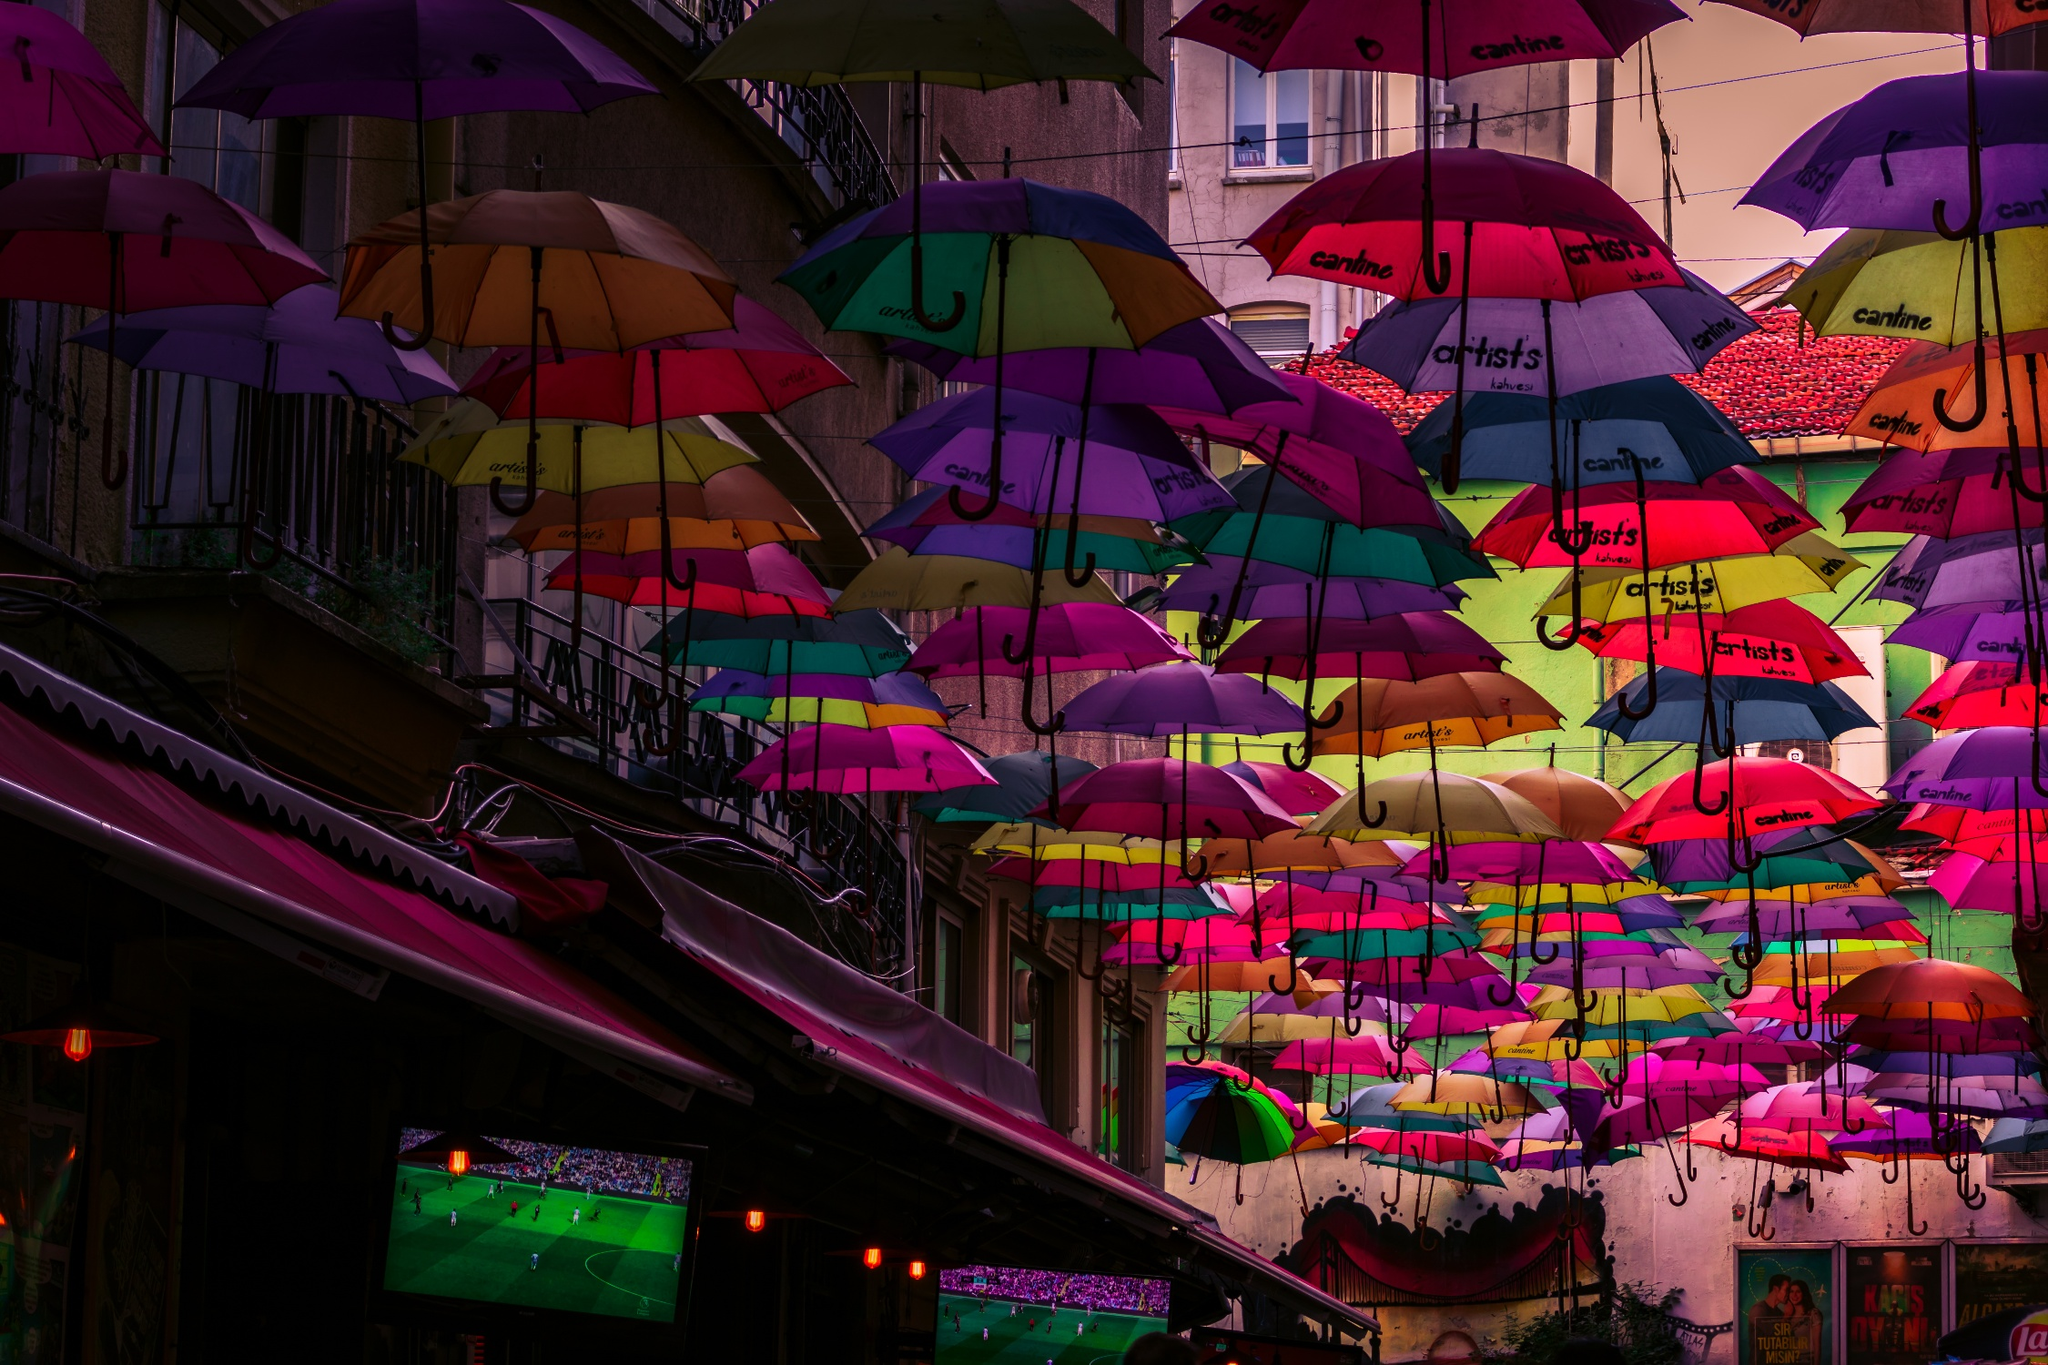What might be the impact of this colorful canopy on the local businesses? The colorful canopy of umbrellas likely boosts local commerce by drawing more visitors to the area, intrigued by the visual spectacle and vibrant atmosphere. It can enhance the street's appeal, making it a popular spot for photographs and leisurely strolls. This increased foot traffic can lead to higher sales in the nearby shops and restaurants, and the umbrellas themselves, showcasing brand names, might reflect sponsorships that help fund community events or beautification efforts. 